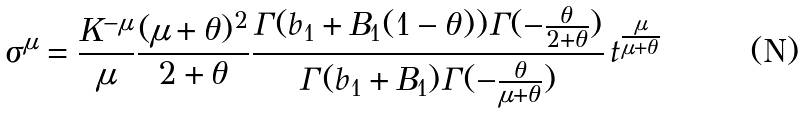<formula> <loc_0><loc_0><loc_500><loc_500>\sigma ^ { \mu } = \frac { K ^ { - \mu } } { \mu } \frac { ( \mu + \theta ) ^ { 2 } } { 2 + \theta } \frac { \Gamma ( b _ { 1 } + B _ { 1 } ( 1 - \theta ) ) \Gamma ( - \frac { \theta } { 2 + \theta } ) } { \Gamma ( b _ { 1 } + B _ { 1 } ) \Gamma ( - \frac { \theta } { \mu + \theta } ) } \, t ^ { \frac { \mu } { \mu + \theta } }</formula> 